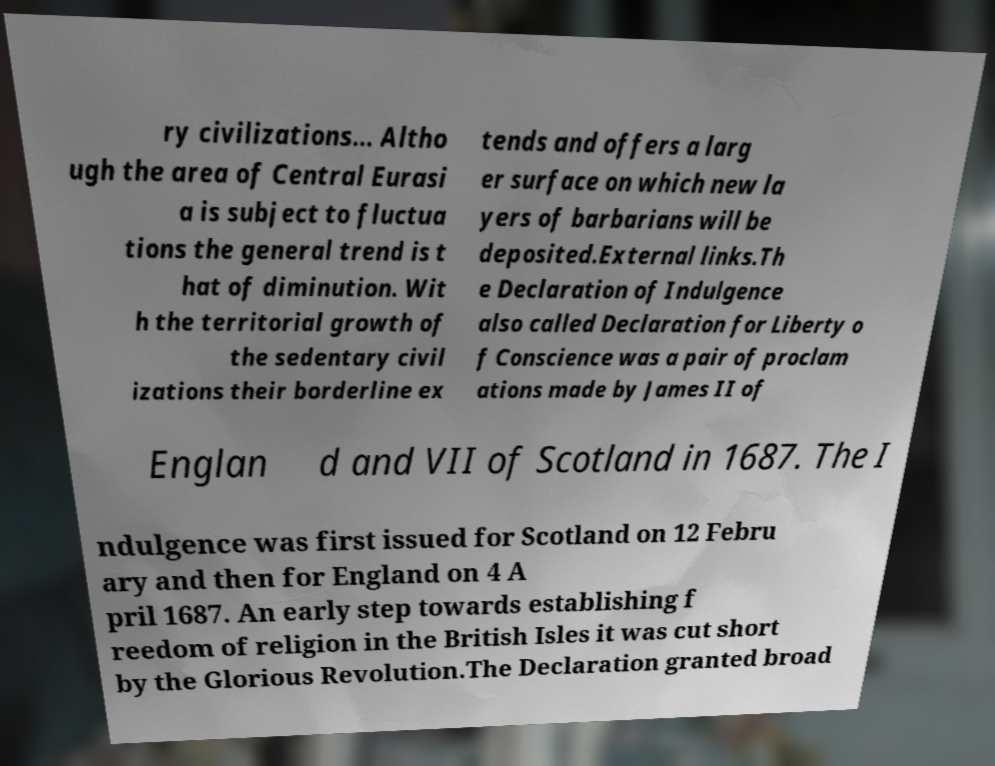For documentation purposes, I need the text within this image transcribed. Could you provide that? ry civilizations... Altho ugh the area of Central Eurasi a is subject to fluctua tions the general trend is t hat of diminution. Wit h the territorial growth of the sedentary civil izations their borderline ex tends and offers a larg er surface on which new la yers of barbarians will be deposited.External links.Th e Declaration of Indulgence also called Declaration for Liberty o f Conscience was a pair of proclam ations made by James II of Englan d and VII of Scotland in 1687. The I ndulgence was first issued for Scotland on 12 Febru ary and then for England on 4 A pril 1687. An early step towards establishing f reedom of religion in the British Isles it was cut short by the Glorious Revolution.The Declaration granted broad 